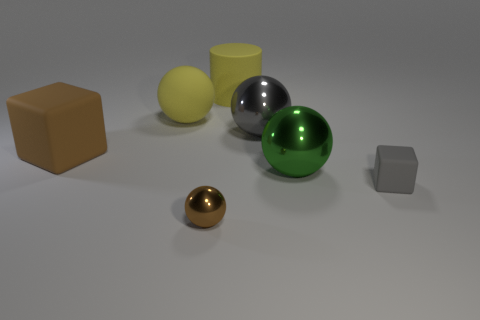Does the gray object that is right of the gray metallic object have the same material as the large ball that is in front of the large cube?
Provide a short and direct response. No. What is the size of the yellow rubber thing that is right of the large yellow rubber ball that is behind the brown metallic ball?
Your answer should be very brief. Large. Is there a big metal thing that has the same color as the small block?
Keep it short and to the point. Yes. Is the color of the tiny thing behind the small metallic ball the same as the sphere to the left of the tiny brown shiny object?
Your answer should be compact. No. What shape is the small brown thing?
Your response must be concise. Sphere. What number of large brown matte things are on the left side of the green object?
Give a very brief answer. 1. What number of other blocks are made of the same material as the tiny gray block?
Your answer should be very brief. 1. Is the material of the ball that is in front of the gray rubber thing the same as the big gray sphere?
Give a very brief answer. Yes. Is there a shiny ball?
Offer a very short reply. Yes. There is a object that is in front of the green metallic ball and right of the cylinder; what size is it?
Provide a short and direct response. Small. 